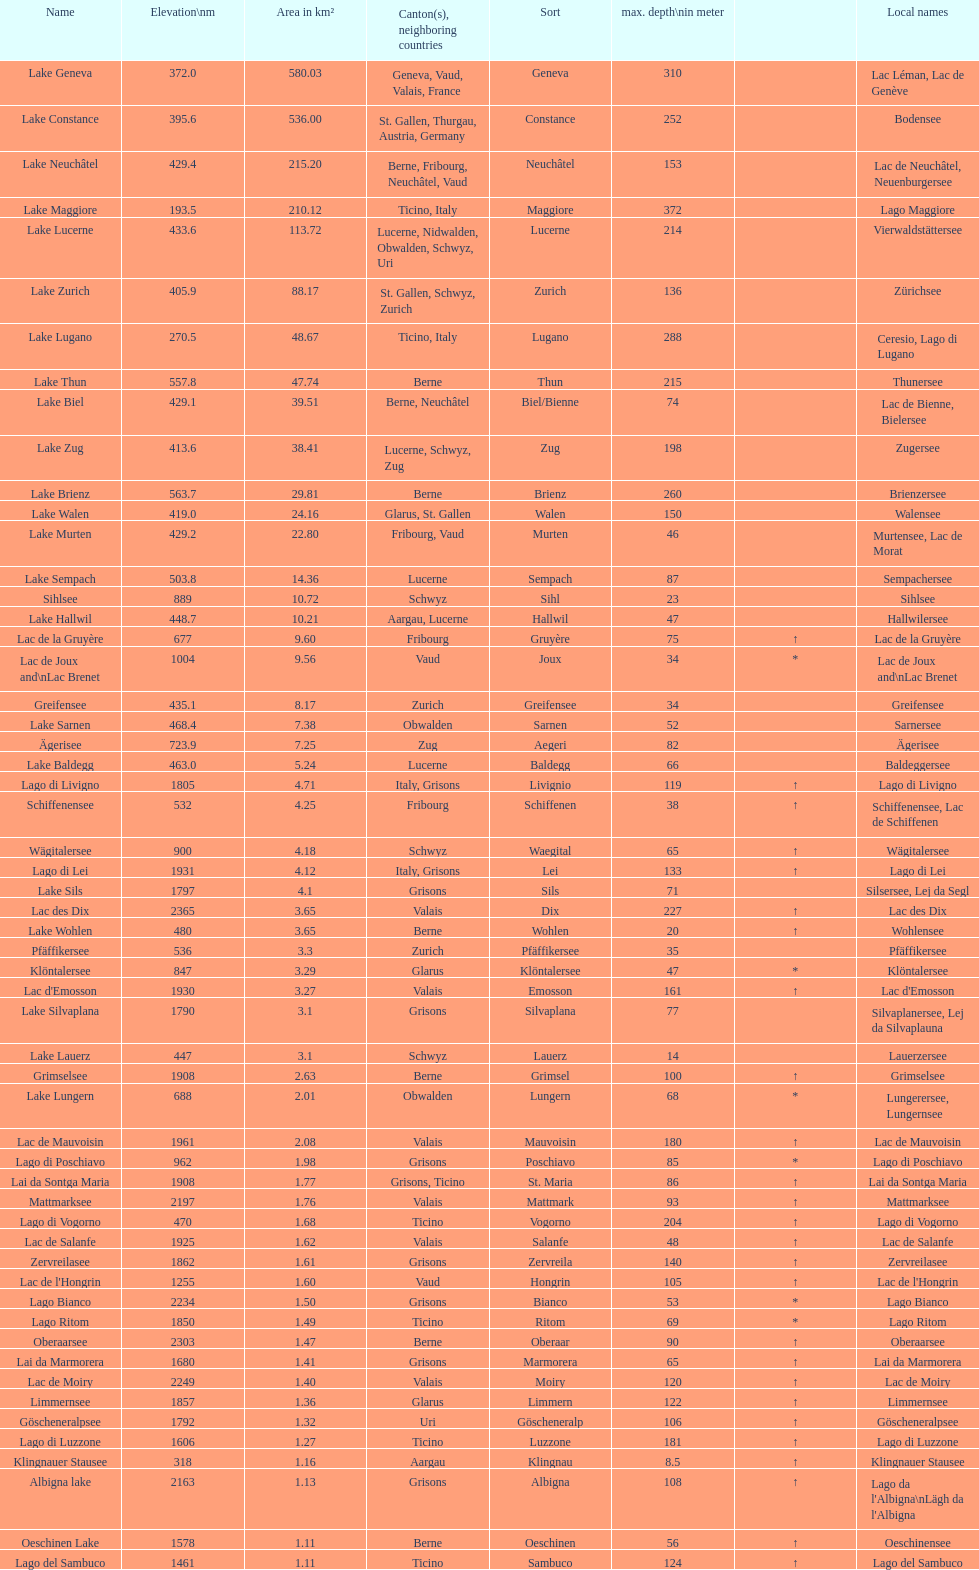What is the total area in km² of lake sils? 4.1. 